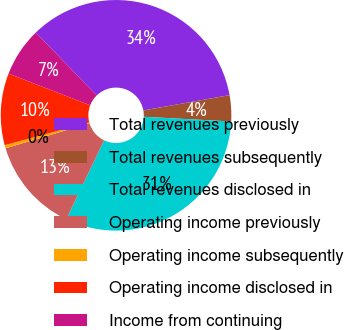Convert chart to OTSL. <chart><loc_0><loc_0><loc_500><loc_500><pie_chart><fcel>Total revenues previously<fcel>Total revenues subsequently<fcel>Total revenues disclosed in<fcel>Operating income previously<fcel>Operating income subsequently<fcel>Operating income disclosed in<fcel>Income from continuing<nl><fcel>34.46%<fcel>3.65%<fcel>31.26%<fcel>13.27%<fcel>0.45%<fcel>10.06%<fcel>6.86%<nl></chart> 